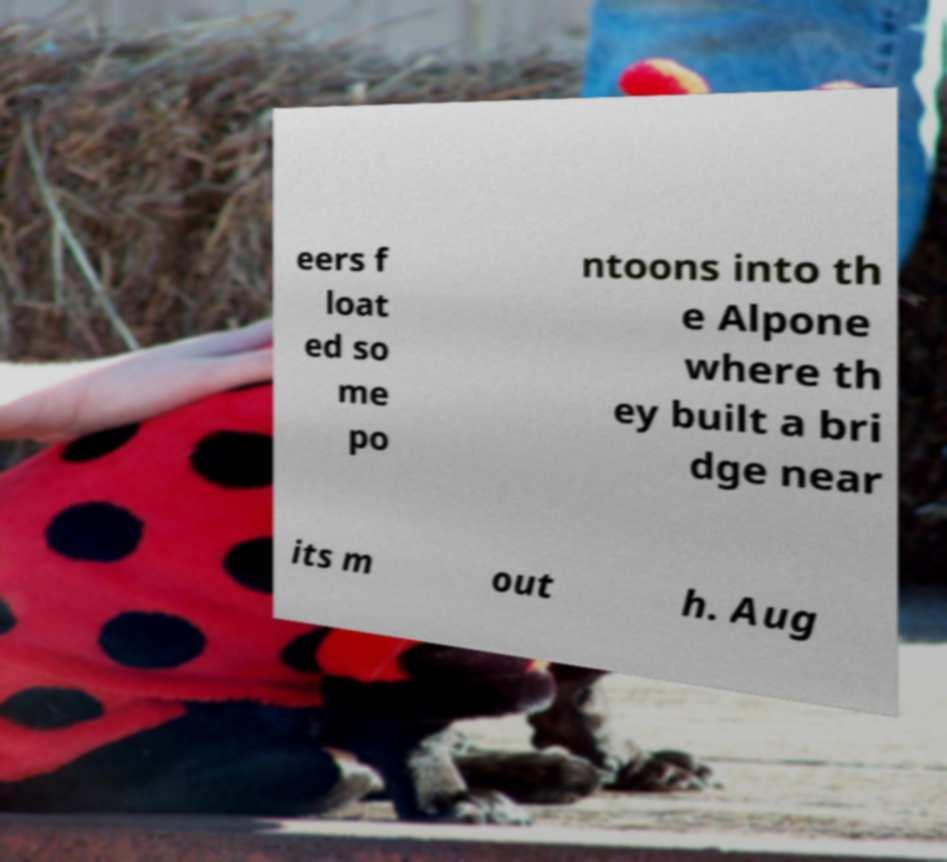Please read and relay the text visible in this image. What does it say? eers f loat ed so me po ntoons into th e Alpone where th ey built a bri dge near its m out h. Aug 